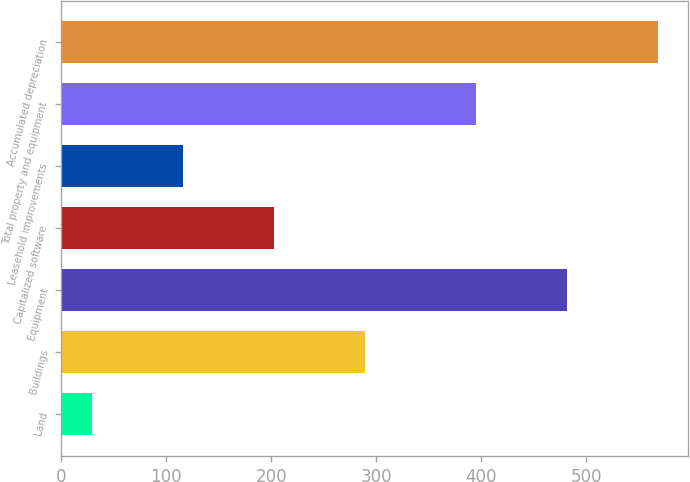Convert chart to OTSL. <chart><loc_0><loc_0><loc_500><loc_500><bar_chart><fcel>Land<fcel>Buildings<fcel>Equipment<fcel>Capitalized software<fcel>Leasehold improvements<fcel>Total property and equipment<fcel>Accumulated depreciation<nl><fcel>29<fcel>289.4<fcel>481.8<fcel>202.6<fcel>115.8<fcel>395<fcel>568.6<nl></chart> 